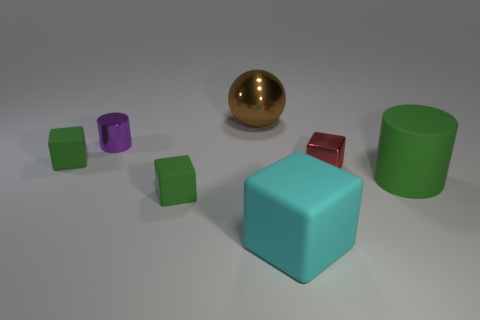How many matte cubes are right of the small purple shiny object?
Provide a succinct answer. 2. What number of things are either large cyan shiny balls or small things to the left of the brown shiny sphere?
Your answer should be compact. 3. There is a small green rubber object behind the green cylinder; are there any big rubber blocks behind it?
Ensure brevity in your answer.  No. The cylinder on the right side of the tiny metallic cylinder is what color?
Provide a short and direct response. Green. Are there the same number of large brown metallic balls that are in front of the large cylinder and tiny gray spheres?
Offer a terse response. Yes. There is a large thing that is both in front of the purple cylinder and behind the large cyan rubber block; what shape is it?
Provide a succinct answer. Cylinder. The large rubber object that is the same shape as the red shiny object is what color?
Provide a short and direct response. Cyan. Is there any other thing that has the same color as the shiny ball?
Make the answer very short. No. There is a small green thing left of the small green rubber object that is on the right side of the small green matte block behind the metallic block; what shape is it?
Your answer should be very brief. Cube. There is a green matte object that is behind the big green cylinder; is it the same size as the green matte cube that is in front of the red block?
Your answer should be very brief. Yes. 